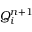Convert formula to latex. <formula><loc_0><loc_0><loc_500><loc_500>Q _ { i } ^ { n + 1 }</formula> 